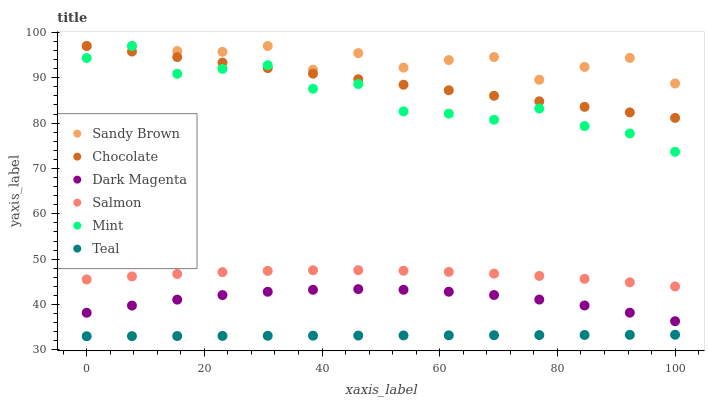Does Teal have the minimum area under the curve?
Answer yes or no. Yes. Does Sandy Brown have the maximum area under the curve?
Answer yes or no. Yes. Does Salmon have the minimum area under the curve?
Answer yes or no. No. Does Salmon have the maximum area under the curve?
Answer yes or no. No. Is Teal the smoothest?
Answer yes or no. Yes. Is Mint the roughest?
Answer yes or no. Yes. Is Sandy Brown the smoothest?
Answer yes or no. No. Is Sandy Brown the roughest?
Answer yes or no. No. Does Teal have the lowest value?
Answer yes or no. Yes. Does Salmon have the lowest value?
Answer yes or no. No. Does Mint have the highest value?
Answer yes or no. Yes. Does Salmon have the highest value?
Answer yes or no. No. Is Teal less than Sandy Brown?
Answer yes or no. Yes. Is Salmon greater than Dark Magenta?
Answer yes or no. Yes. Does Sandy Brown intersect Mint?
Answer yes or no. Yes. Is Sandy Brown less than Mint?
Answer yes or no. No. Is Sandy Brown greater than Mint?
Answer yes or no. No. Does Teal intersect Sandy Brown?
Answer yes or no. No. 